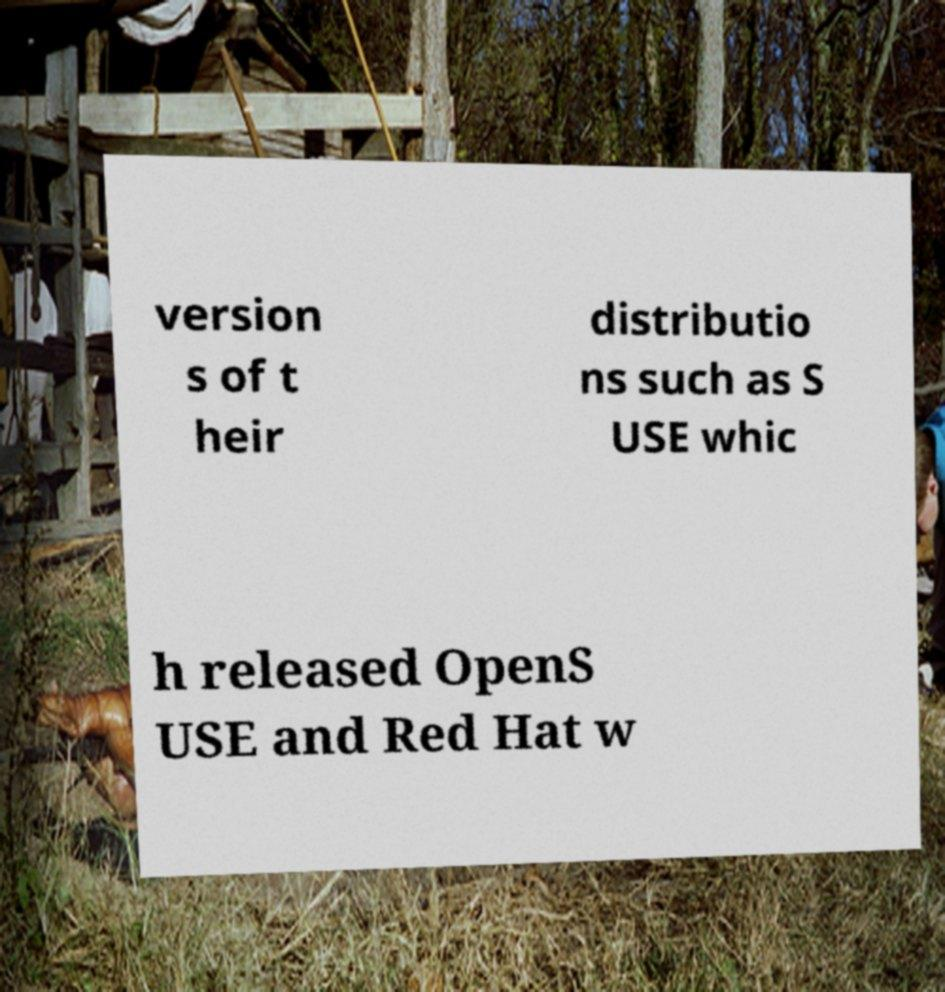Please identify and transcribe the text found in this image. version s of t heir distributio ns such as S USE whic h released OpenS USE and Red Hat w 